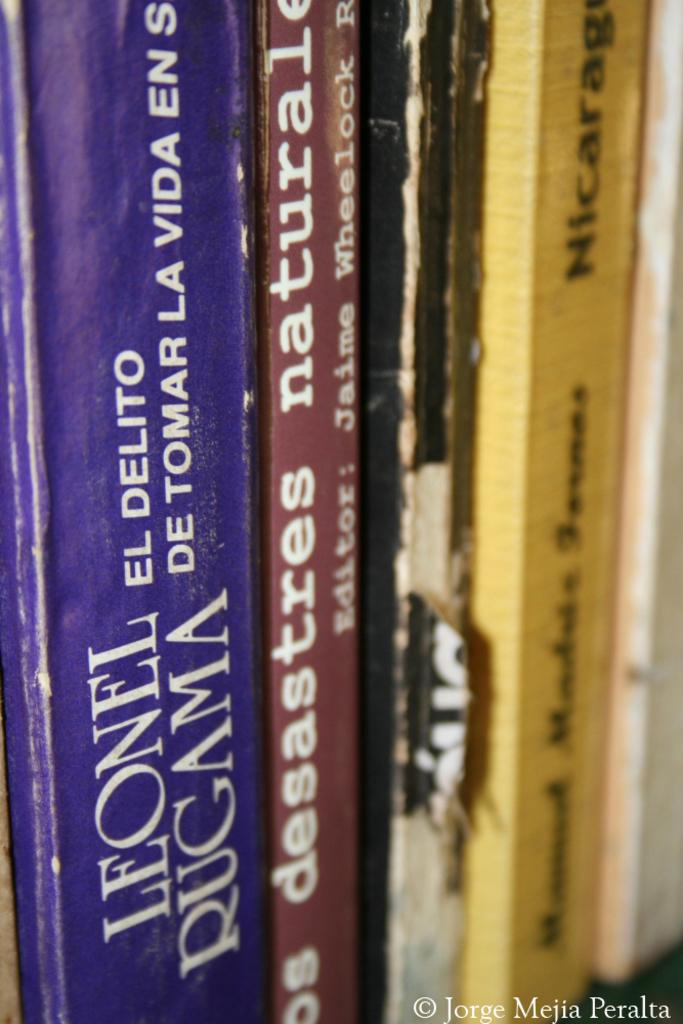Provide a one-sentence caption for the provided image. A collection of books including one written by Leonel Rugama. 